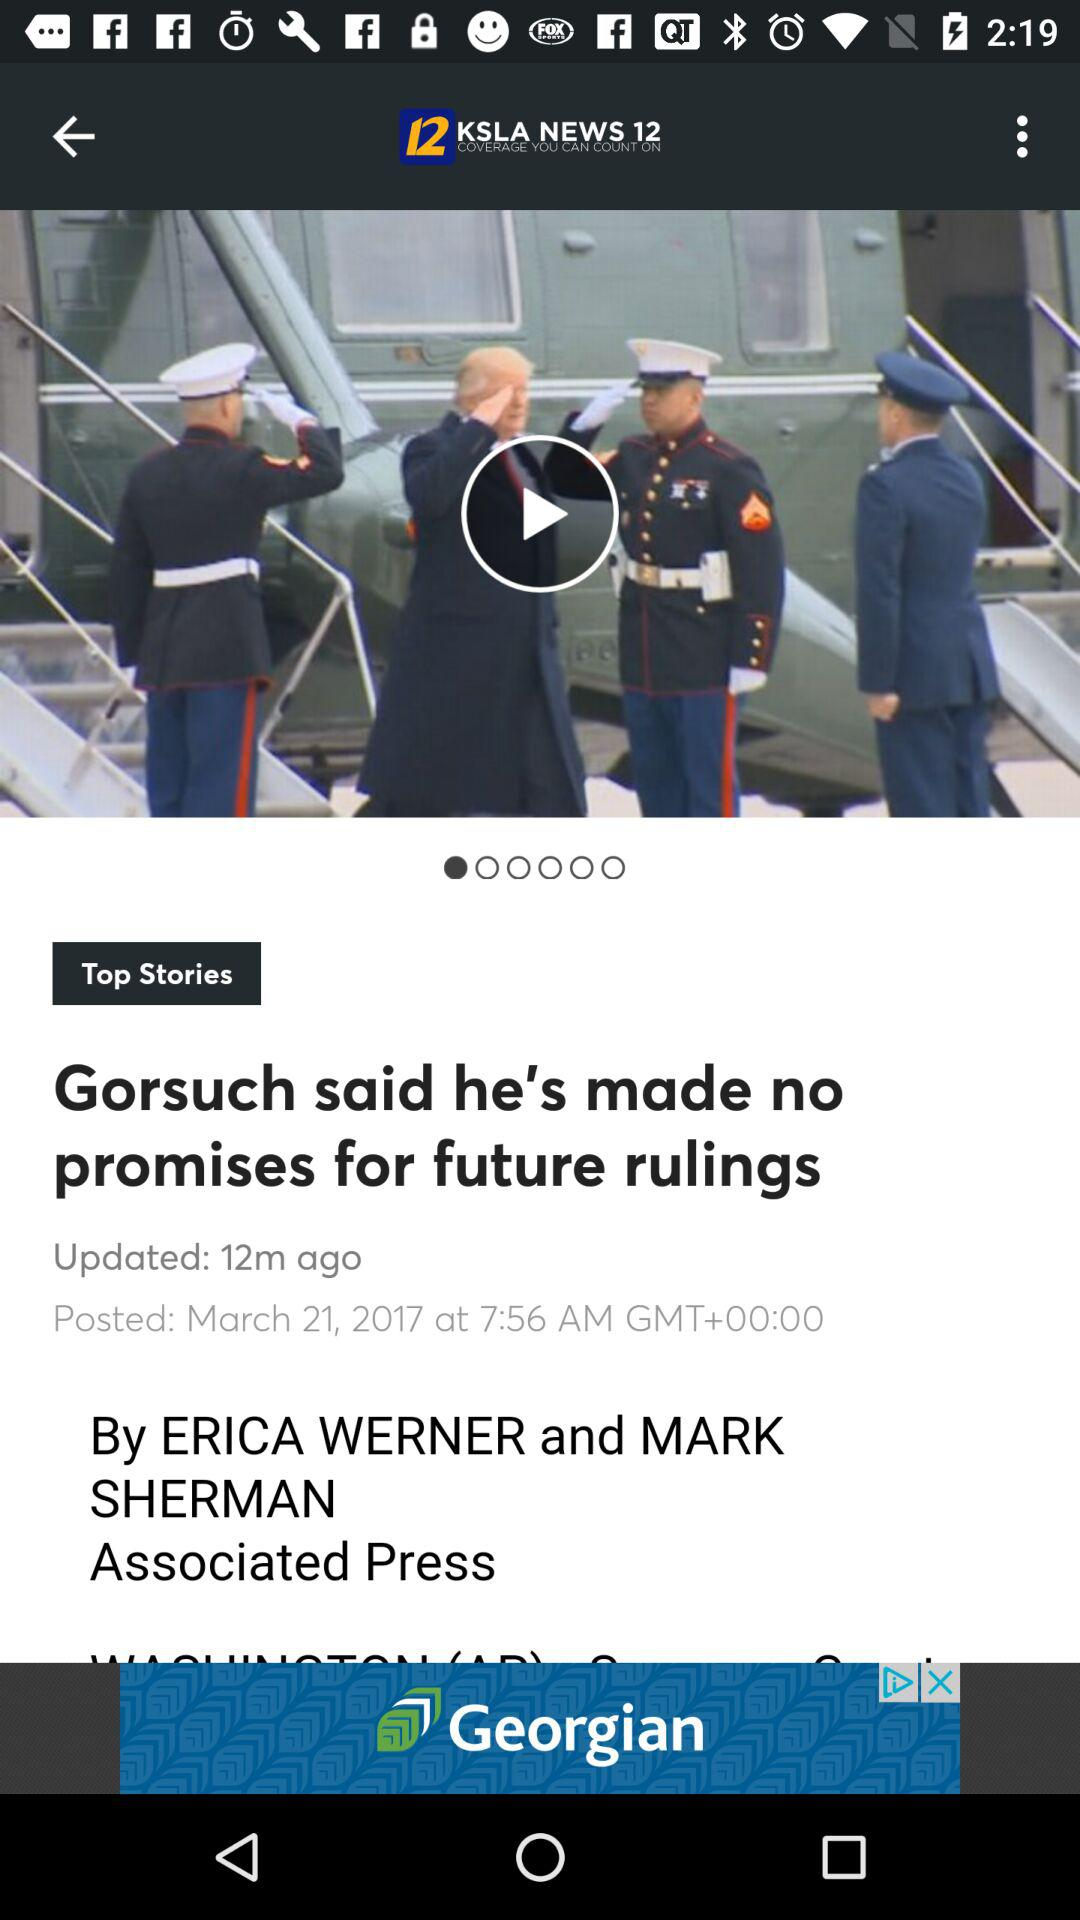What is the news channel name? The news channel name is "KSLA NEWS 12". 